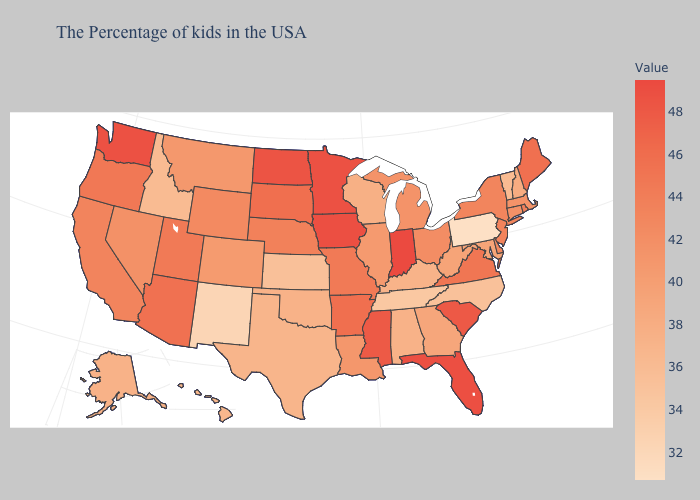Among the states that border Utah , which have the highest value?
Concise answer only. Arizona. Does Arkansas have the highest value in the South?
Keep it brief. No. Does Pennsylvania have the lowest value in the USA?
Write a very short answer. Yes. Which states have the lowest value in the West?
Short answer required. New Mexico. Among the states that border Tennessee , which have the highest value?
Write a very short answer. Mississippi. 